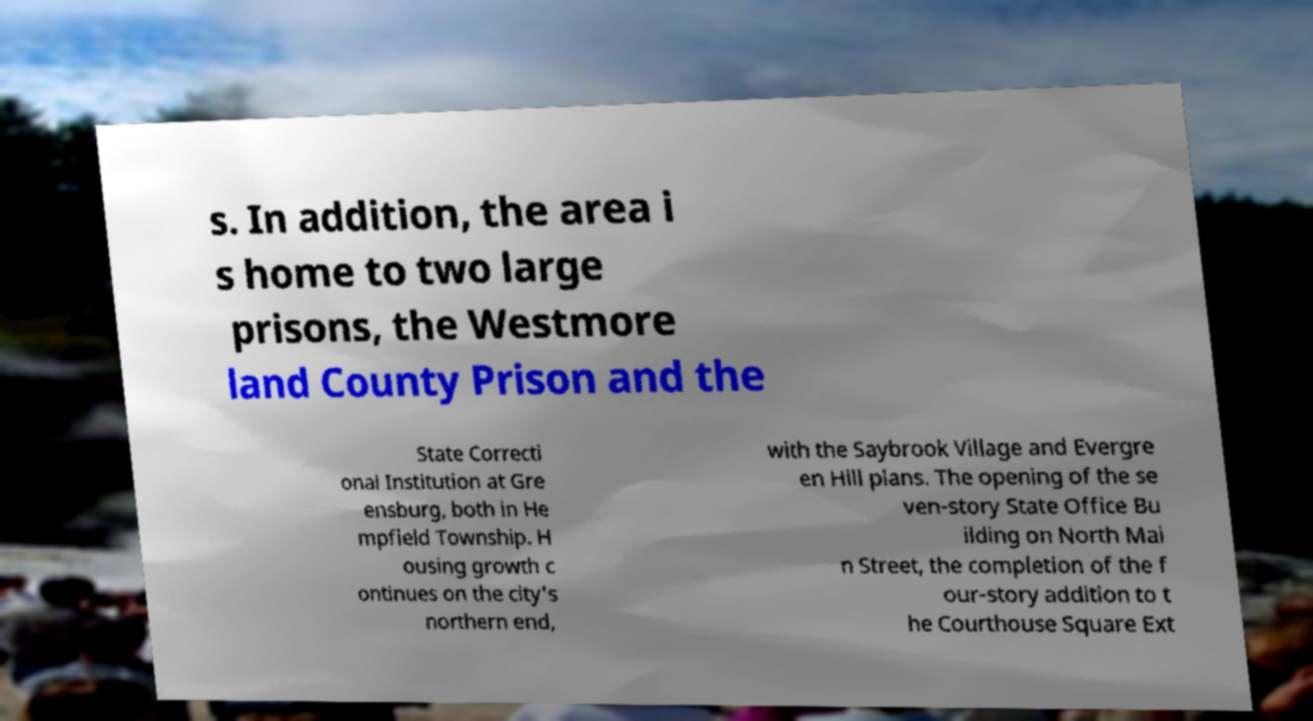Please read and relay the text visible in this image. What does it say? s. In addition, the area i s home to two large prisons, the Westmore land County Prison and the State Correcti onal Institution at Gre ensburg, both in He mpfield Township. H ousing growth c ontinues on the city's northern end, with the Saybrook Village and Evergre en Hill plans. The opening of the se ven-story State Office Bu ilding on North Mai n Street, the completion of the f our-story addition to t he Courthouse Square Ext 